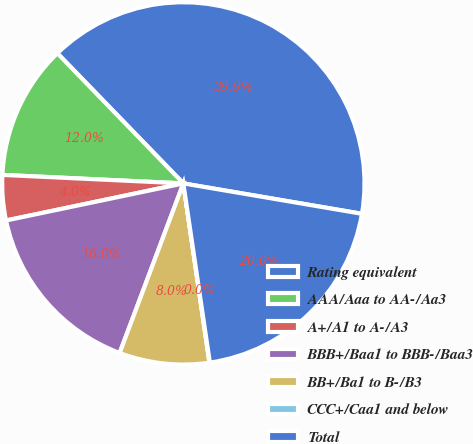<chart> <loc_0><loc_0><loc_500><loc_500><pie_chart><fcel>Rating equivalent<fcel>AAA/Aaa to AA-/Aa3<fcel>A+/A1 to A-/A3<fcel>BBB+/Baa1 to BBB-/Baa3<fcel>BB+/Ba1 to B-/B3<fcel>CCC+/Caa1 and below<fcel>Total<nl><fcel>39.93%<fcel>12.01%<fcel>4.03%<fcel>16.0%<fcel>8.02%<fcel>0.04%<fcel>19.98%<nl></chart> 